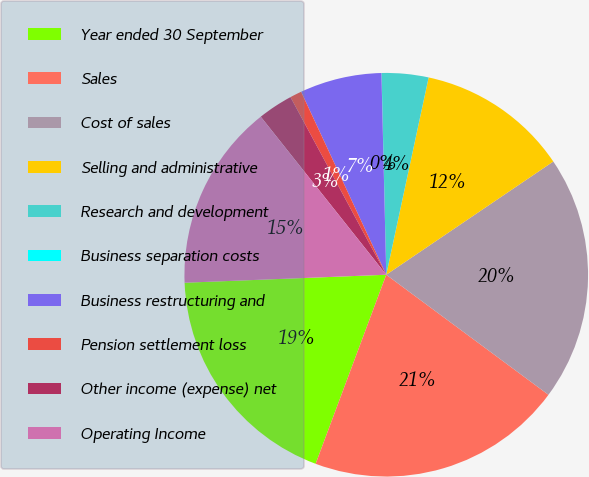Convert chart. <chart><loc_0><loc_0><loc_500><loc_500><pie_chart><fcel>Year ended 30 September<fcel>Sales<fcel>Cost of sales<fcel>Selling and administrative<fcel>Research and development<fcel>Business separation costs<fcel>Business restructuring and<fcel>Pension settlement loss<fcel>Other income (expense) net<fcel>Operating Income<nl><fcel>18.68%<fcel>20.55%<fcel>19.62%<fcel>12.15%<fcel>3.74%<fcel>0.01%<fcel>6.55%<fcel>0.94%<fcel>2.81%<fcel>14.95%<nl></chart> 